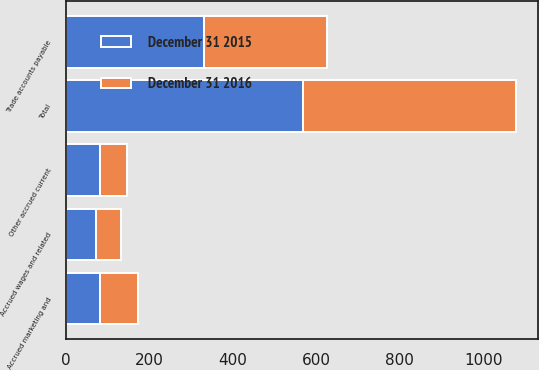<chart> <loc_0><loc_0><loc_500><loc_500><stacked_bar_chart><ecel><fcel>Trade accounts payable<fcel>Accrued marketing and<fcel>Accrued wages and related<fcel>Other accrued current<fcel>Total<nl><fcel>December 31 2015<fcel>331.6<fcel>82<fcel>73.2<fcel>82.1<fcel>568.9<nl><fcel>December 31 2016<fcel>293.9<fcel>91.5<fcel>59.4<fcel>63.5<fcel>508.3<nl></chart> 